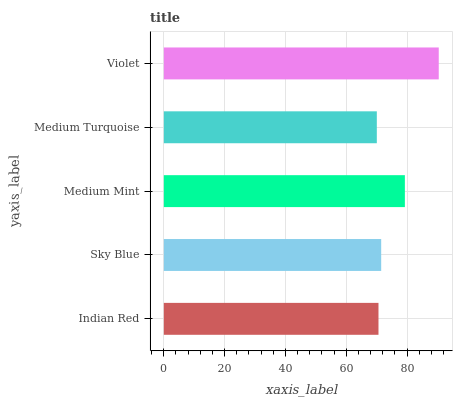Is Medium Turquoise the minimum?
Answer yes or no. Yes. Is Violet the maximum?
Answer yes or no. Yes. Is Sky Blue the minimum?
Answer yes or no. No. Is Sky Blue the maximum?
Answer yes or no. No. Is Sky Blue greater than Indian Red?
Answer yes or no. Yes. Is Indian Red less than Sky Blue?
Answer yes or no. Yes. Is Indian Red greater than Sky Blue?
Answer yes or no. No. Is Sky Blue less than Indian Red?
Answer yes or no. No. Is Sky Blue the high median?
Answer yes or no. Yes. Is Sky Blue the low median?
Answer yes or no. Yes. Is Violet the high median?
Answer yes or no. No. Is Medium Mint the low median?
Answer yes or no. No. 